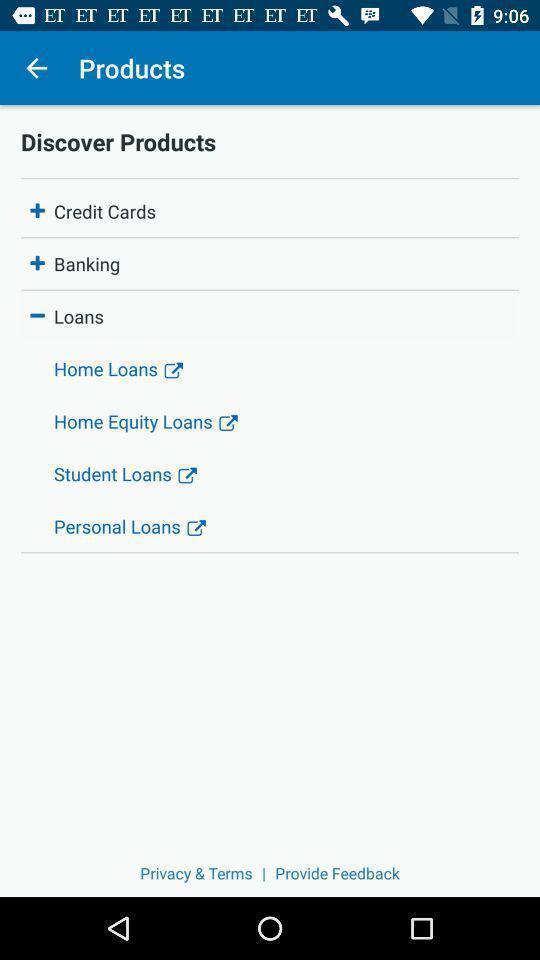Provide a detailed account of this screenshot. Various categories in a banking app. 